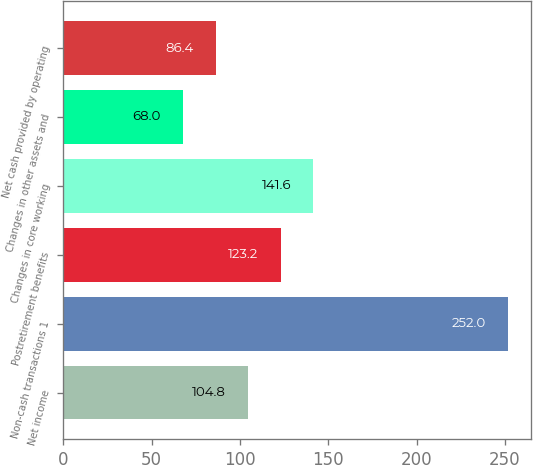Convert chart. <chart><loc_0><loc_0><loc_500><loc_500><bar_chart><fcel>Net income<fcel>Non-cash transactions 1<fcel>Postretirement benefits<fcel>Changes in core working<fcel>Changes in other assets and<fcel>Net cash provided by operating<nl><fcel>104.8<fcel>252<fcel>123.2<fcel>141.6<fcel>68<fcel>86.4<nl></chart> 